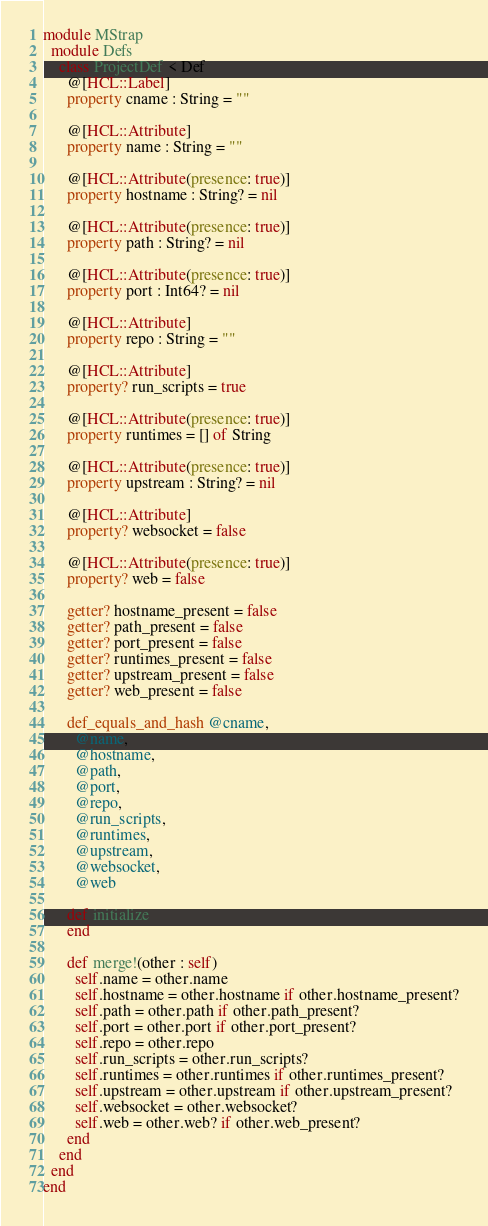<code> <loc_0><loc_0><loc_500><loc_500><_Crystal_>module MStrap
  module Defs
    class ProjectDef < Def
      @[HCL::Label]
      property cname : String = ""

      @[HCL::Attribute]
      property name : String = ""

      @[HCL::Attribute(presence: true)]
      property hostname : String? = nil

      @[HCL::Attribute(presence: true)]
      property path : String? = nil

      @[HCL::Attribute(presence: true)]
      property port : Int64? = nil

      @[HCL::Attribute]
      property repo : String = ""

      @[HCL::Attribute]
      property? run_scripts = true

      @[HCL::Attribute(presence: true)]
      property runtimes = [] of String

      @[HCL::Attribute(presence: true)]
      property upstream : String? = nil

      @[HCL::Attribute]
      property? websocket = false

      @[HCL::Attribute(presence: true)]
      property? web = false

      getter? hostname_present = false
      getter? path_present = false
      getter? port_present = false
      getter? runtimes_present = false
      getter? upstream_present = false
      getter? web_present = false

      def_equals_and_hash @cname,
        @name,
        @hostname,
        @path,
        @port,
        @repo,
        @run_scripts,
        @runtimes,
        @upstream,
        @websocket,
        @web

      def initialize
      end

      def merge!(other : self)
        self.name = other.name
        self.hostname = other.hostname if other.hostname_present?
        self.path = other.path if other.path_present?
        self.port = other.port if other.port_present?
        self.repo = other.repo
        self.run_scripts = other.run_scripts?
        self.runtimes = other.runtimes if other.runtimes_present?
        self.upstream = other.upstream if other.upstream_present?
        self.websocket = other.websocket?
        self.web = other.web? if other.web_present?
      end
    end
  end
end
</code> 